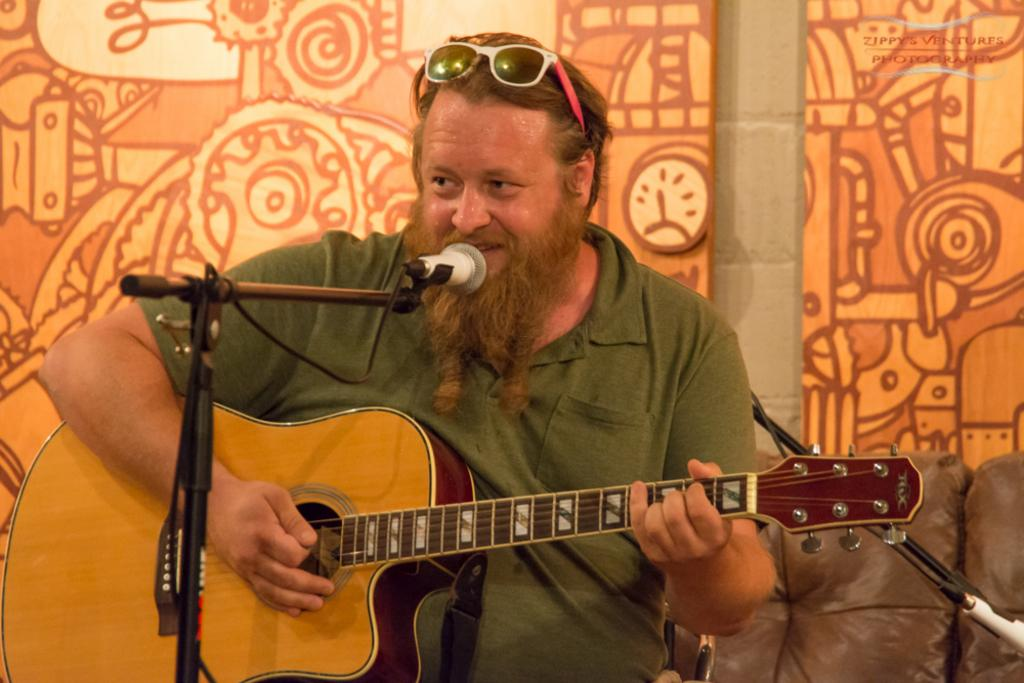What is the man in the image doing? The man is sitting in the image and playing a guitar. What is the man wearing in the image? The man is wearing a green t-shirt in the image. What object is in front of the man? There is a microphone in front of the man in the image. What type of corn is being blown by the man in the image? There is no corn or blowing activity present in the image; the man is playing a guitar and there is a microphone in front of him. 